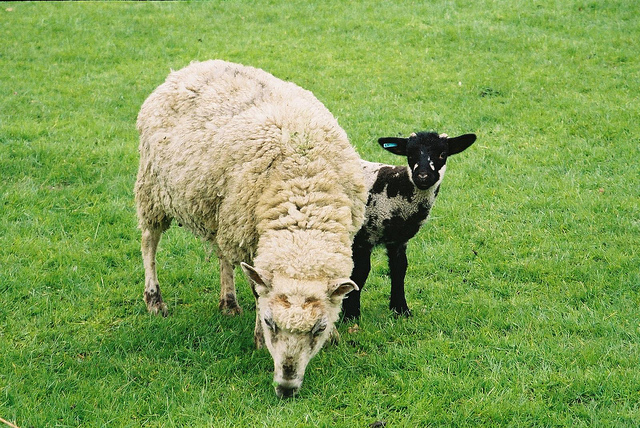<image>How old is the baby sheep? It's ambiguous to determine the age of the baby sheep. How old is the baby sheep? I don't know how old is the baby sheep. It can be 6 months, 2 months, 4 weeks or newborn. 